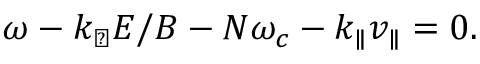<formula> <loc_0><loc_0><loc_500><loc_500>\omega - k _ { \perp } E / B - N \omega _ { c } - k _ { \| } v _ { \| } = 0 .</formula> 